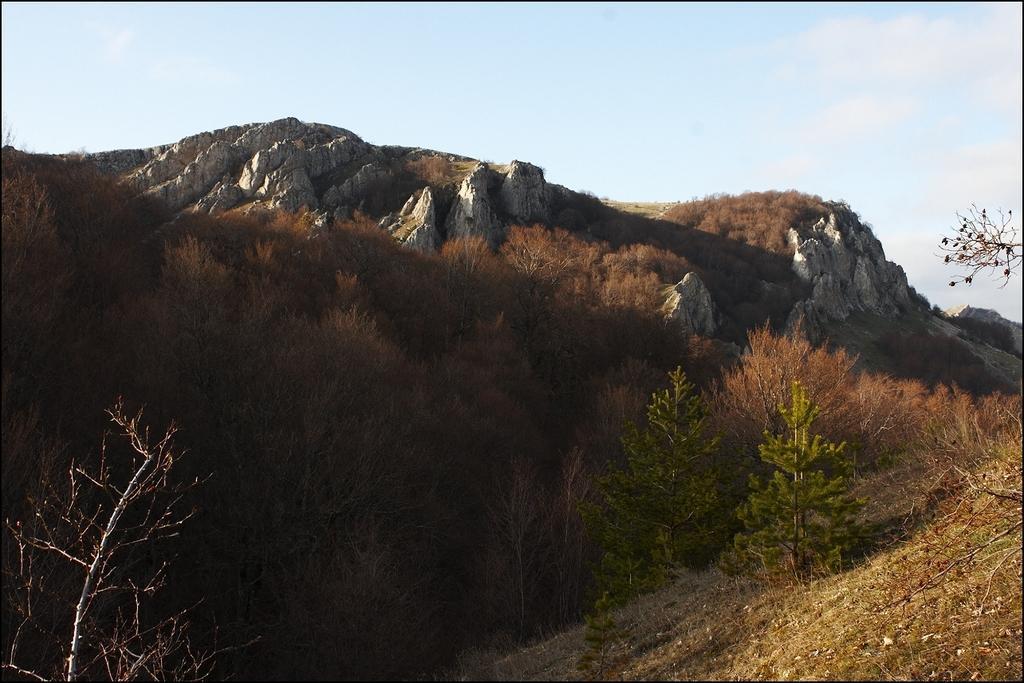How would you summarize this image in a sentence or two? In the image there is a hill and around the hill there's a lot of dry grass and trees. 